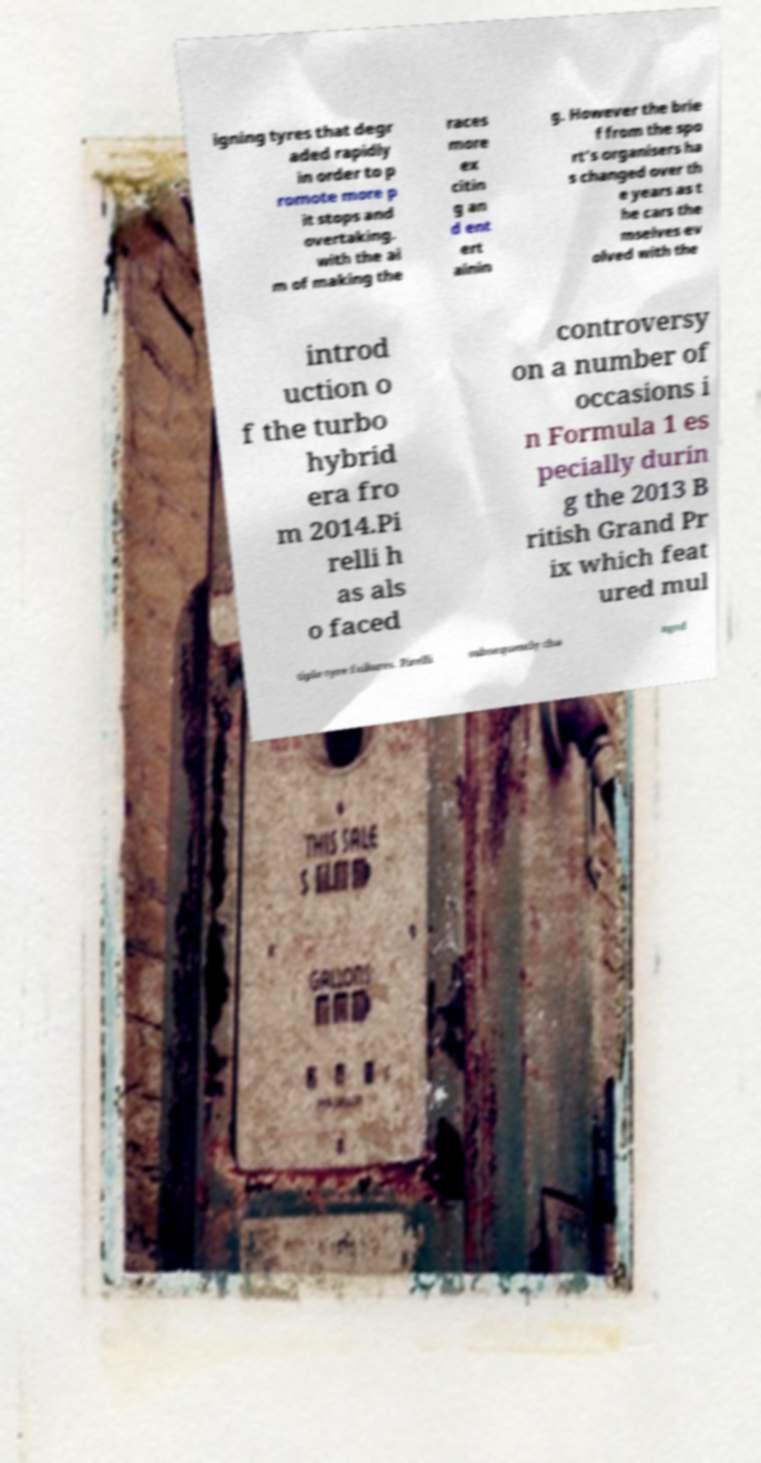I need the written content from this picture converted into text. Can you do that? igning tyres that degr aded rapidly in order to p romote more p it stops and overtaking. with the ai m of making the races more ex citin g an d ent ert ainin g. However the brie f from the spo rt’s organisers ha s changed over th e years as t he cars the mselves ev olved with the introd uction o f the turbo hybrid era fro m 2014.Pi relli h as als o faced controversy on a number of occasions i n Formula 1 es pecially durin g the 2013 B ritish Grand Pr ix which feat ured mul tiple tyre failures. Pirelli subsequently cha nged 